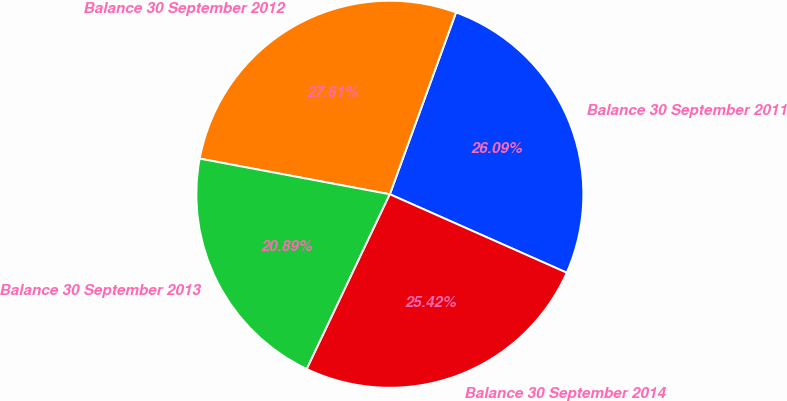<chart> <loc_0><loc_0><loc_500><loc_500><pie_chart><fcel>Balance 30 September 2011<fcel>Balance 30 September 2012<fcel>Balance 30 September 2013<fcel>Balance 30 September 2014<nl><fcel>26.09%<fcel>27.61%<fcel>20.89%<fcel>25.42%<nl></chart> 